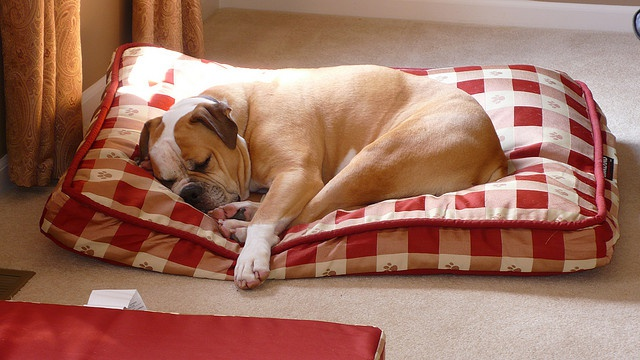Describe the objects in this image and their specific colors. I can see bed in maroon, white, and brown tones and dog in maroon, brown, gray, lightgray, and tan tones in this image. 